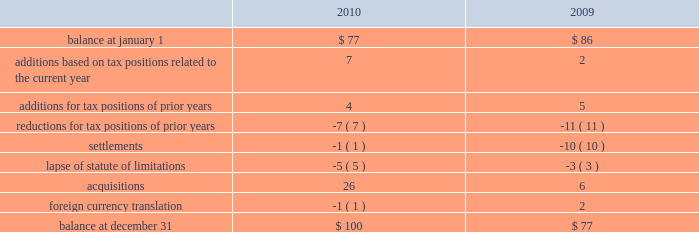Remitted to the u.s .
Due to foreign tax credits and exclusions that may become available at the time of remittance .
At december 31 , 2010 , aon had domestic federal operating loss carryforwards of $ 56 million that will expire at various dates from 2011 to 2024 , state operating loss carryforwards of $ 610 million that will expire at various dates from 2011 to 2031 , and foreign operating and capital loss carryforwards of $ 720 million and $ 251 million , respectively , nearly all of which are subject to indefinite carryforward .
Unrecognized tax provisions the following is a reconciliation of the company 2019s beginning and ending amount of unrecognized tax benefits ( in millions ) : .
As of december 31 , 2010 , $ 85 million of unrecognized tax benefits would impact the effective tax rate if recognized .
Aon does not expect the unrecognized tax positions to change significantly over the next twelve months , except for a potential reduction of unrecognized tax benefits in the range of $ 10-$ 15 million relating to anticipated audit settlements .
The company recognizes penalties and interest related to unrecognized income tax benefits in its provision for income taxes .
Aon accrued potential penalties of less than $ 1 million during each of 2010 , 2009 and 2008 .
Aon accrued interest of less than $ 1 million in 2010 , $ 2 million during 2009 and less than $ 1 million in 2008 .
Aon has recorded a liability for penalties of $ 5 million and for interest of $ 18 million for both december 31 , 2010 and 2009 .
Aon and its subsidiaries file income tax returns in the u.s .
Federal jurisdiction as well as various state and international jurisdictions .
Aon has substantially concluded all u.s .
Federal income tax matters for years through 2006 .
Material u.s .
State and local income tax jurisdiction examinations have been concluded for years through 2002 .
Aon has concluded income tax examinations in its primary international jurisdictions through 2004. .
What percent of unrecognized tax benefits would impact the effective tax rate if recognized in 2010? 
Computations: (85 / 100)
Answer: 0.85. 